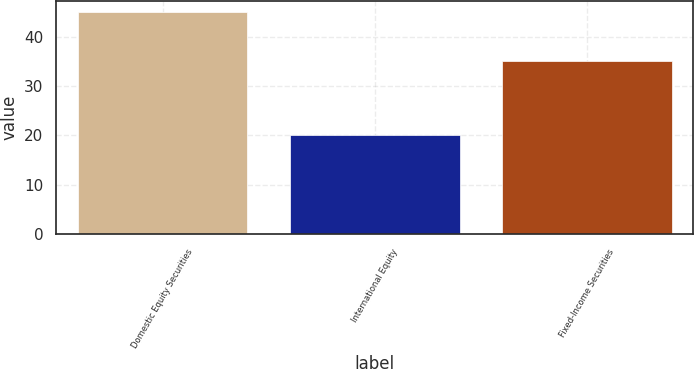Convert chart to OTSL. <chart><loc_0><loc_0><loc_500><loc_500><bar_chart><fcel>Domestic Equity Securities<fcel>International Equity<fcel>Fixed-Income Securities<nl><fcel>45<fcel>20<fcel>35<nl></chart> 